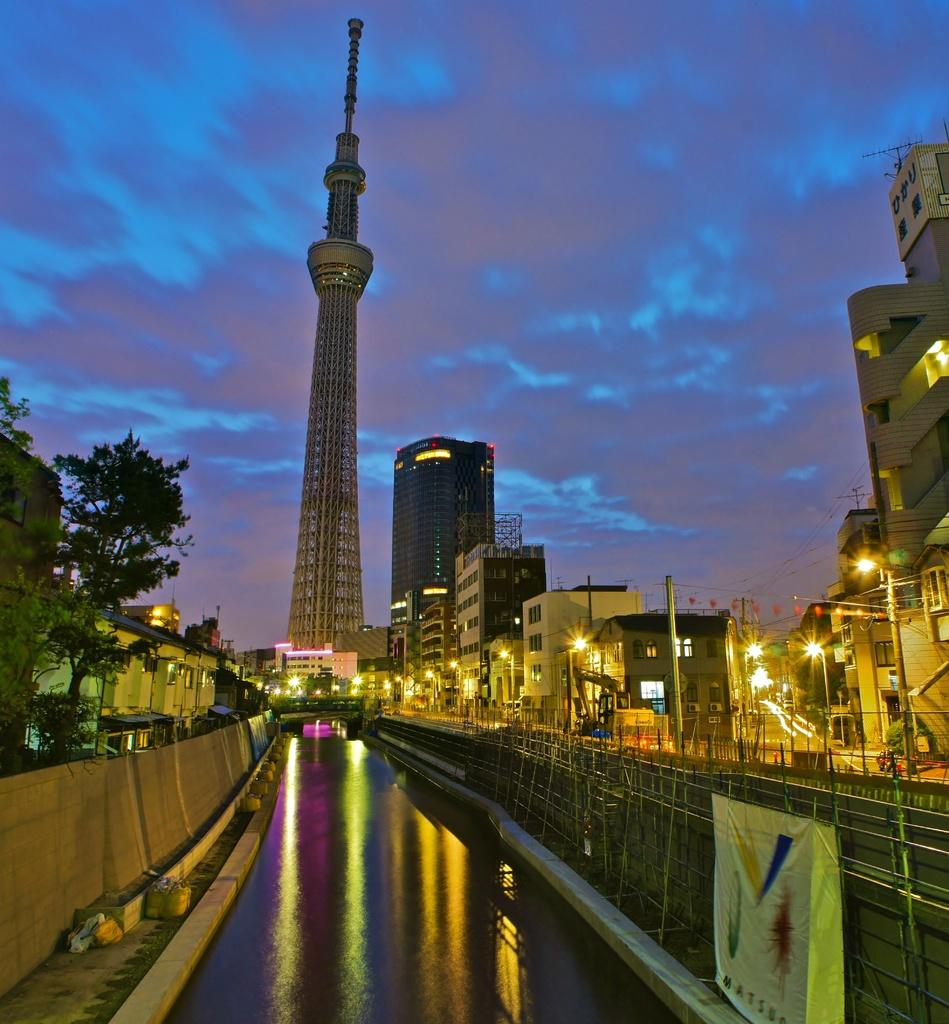What type of location is depicted in the image? The image is of a city. What can be seen in the center of the image? There are buildings, street lights, poles, roads, and a tree in the center of the image. What is present in the foreground of the image? There is a canal and a wall in the foreground of the image. How would you describe the sky in the image? The sky is cloudy in the image. What type of instrument is being played by the person in the image? There is no person visible in the image, and therefore no instrument being played. Can you tell me what the person is writing in the image? There is no person or writing present in the image. 